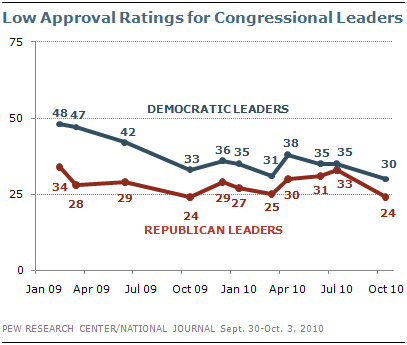List a handful of essential elements in this visual. In the year October 2009, the sum value of Democratic leaders and Republican leaders was 57. I would like to know the number of times the value of 35 appears in Democratic leaders, starting from 3. 